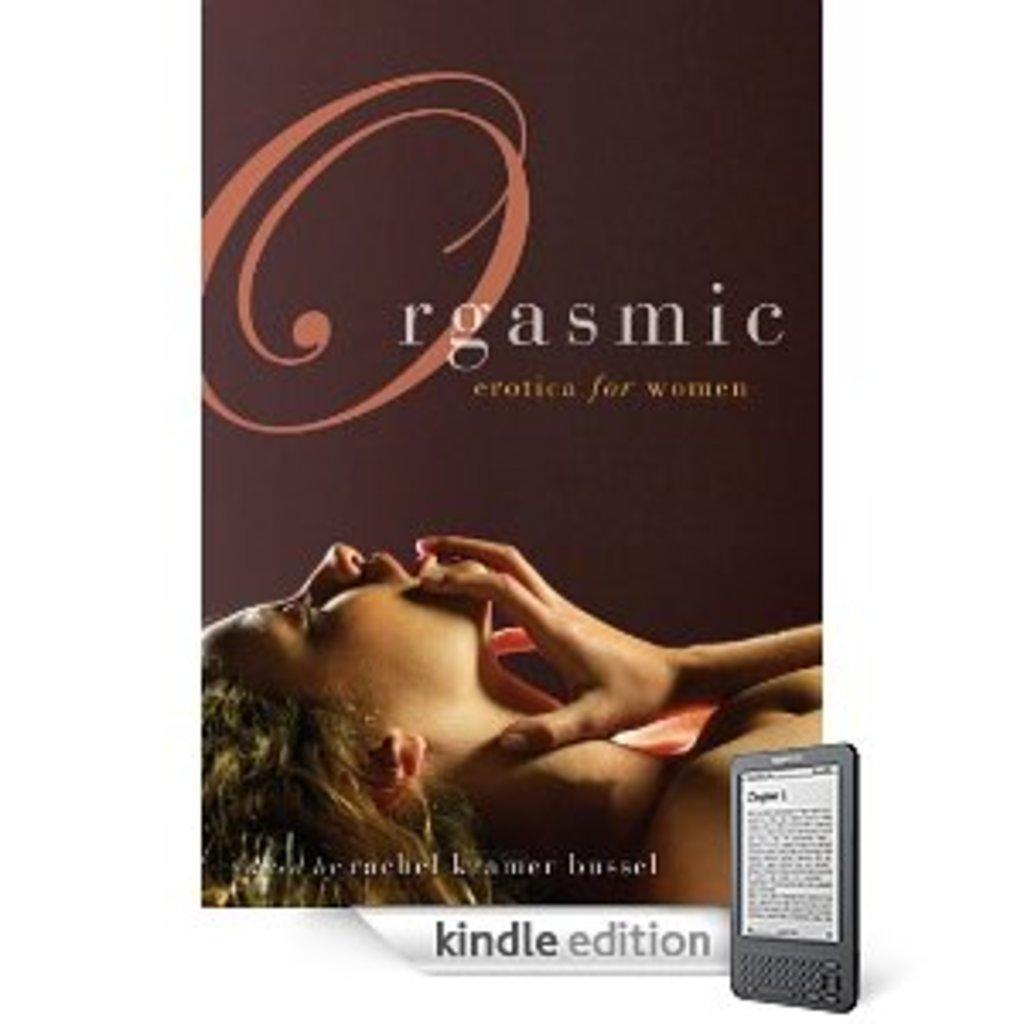What is featured on the poster in the image? The poster has a picture of a woman on it. Is there any text on the poster? Yes, the poster has text on it. What can be seen beside the poster in the image? There is an electronic device beside the poster. How many ducks are visible on the poster? There are no ducks present on the poster; it features a picture of a woman. What word is written in large letters on the poster? There is no specific word mentioned in the provided facts, so we cannot determine which word is written in large letters on the poster. 